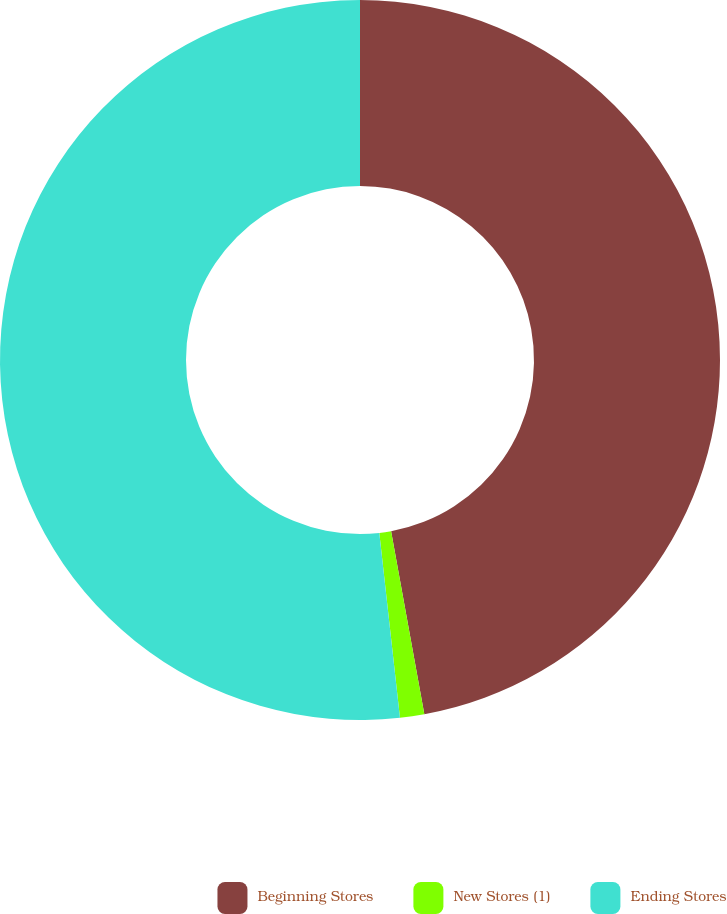<chart> <loc_0><loc_0><loc_500><loc_500><pie_chart><fcel>Beginning Stores<fcel>New Stores (1)<fcel>Ending Stores<nl><fcel>47.14%<fcel>1.09%<fcel>51.77%<nl></chart> 